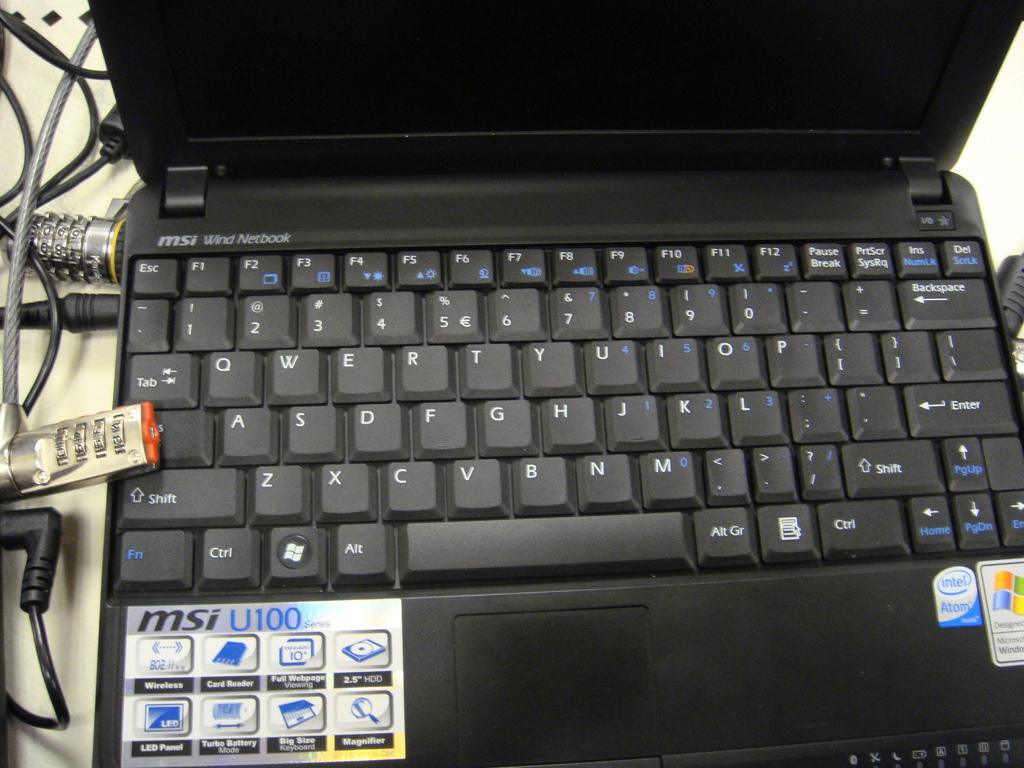What electronic device is present in the image? There is a laptop in the picture. What is the laptop placed on? The laptop is placed on a white surface. Are there any cables connected to the laptop? Yes, the laptop is connected with cables. What are the primary input devices on the laptop? There are keys on the laptop. Are there any additional decorations on the laptop? Yes, there are stickers on the laptop. What type of invention is the manager holding in the image? There is no manager or invention present in the image; it features a laptop placed on a white surface and connected with cables. 